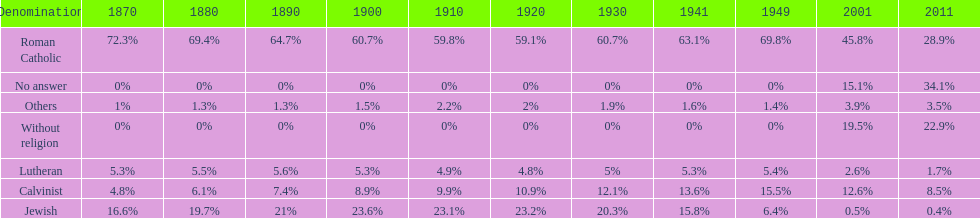In which year was the percentage of those without religion at least 20%? 2011. 